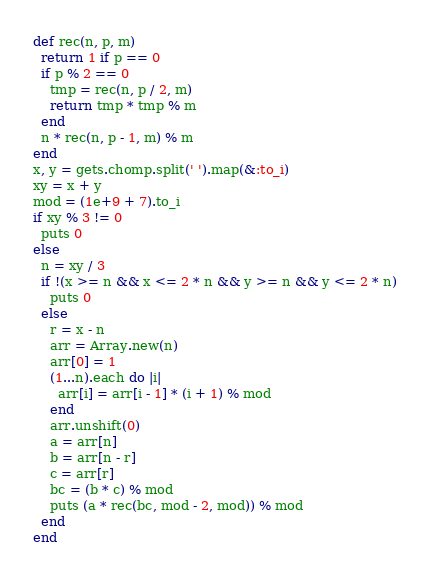<code> <loc_0><loc_0><loc_500><loc_500><_Ruby_>def rec(n, p, m)
  return 1 if p == 0
  if p % 2 == 0
    tmp = rec(n, p / 2, m)
    return tmp * tmp % m
  end
  n * rec(n, p - 1, m) % m
end
x, y = gets.chomp.split(' ').map(&:to_i)
xy = x + y
mod = (1e+9 + 7).to_i
if xy % 3 != 0
  puts 0
else
  n = xy / 3
  if !(x >= n && x <= 2 * n && y >= n && y <= 2 * n)
    puts 0
  else
    r = x - n
    arr = Array.new(n)
    arr[0] = 1
    (1...n).each do |i|
      arr[i] = arr[i - 1] * (i + 1) % mod
    end
    arr.unshift(0)
    a = arr[n]
    b = arr[n - r]
    c = arr[r]
    bc = (b * c) % mod
    puts (a * rec(bc, mod - 2, mod)) % mod
  end
end
</code> 